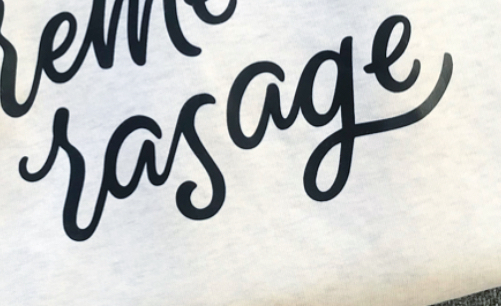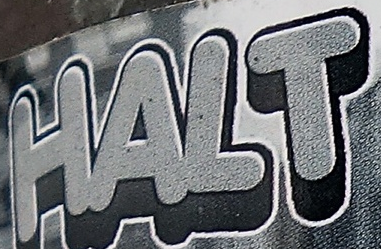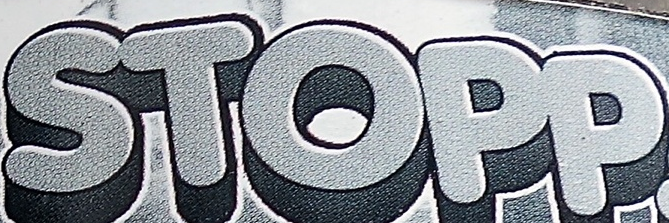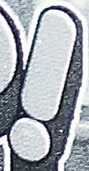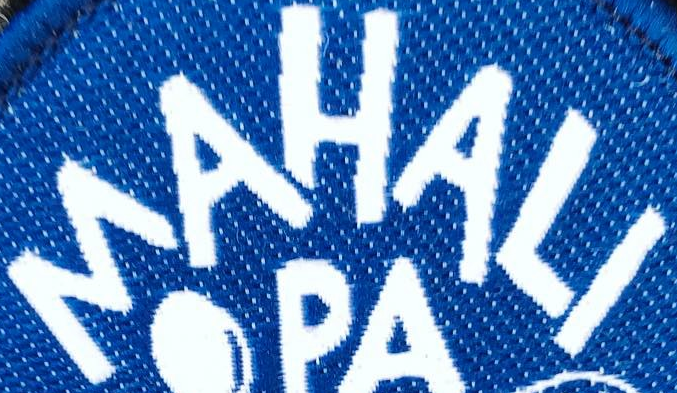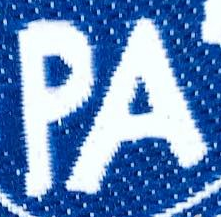Read the text content from these images in order, separated by a semicolon. rasage; HALT; STOPP; !; MAHALI; PA 